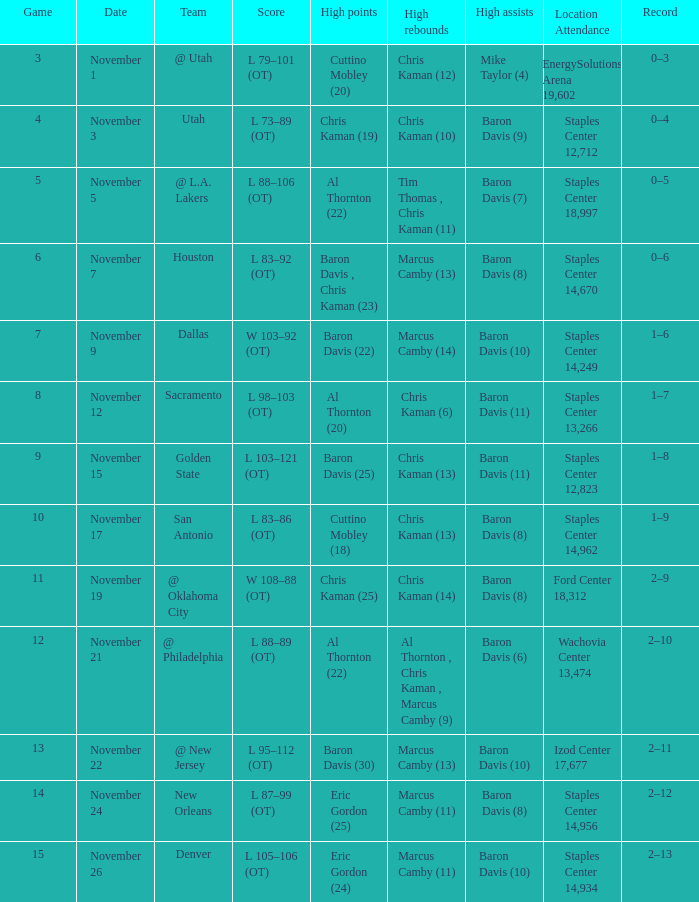Name the high points for the date of november 24 Eric Gordon (25). 